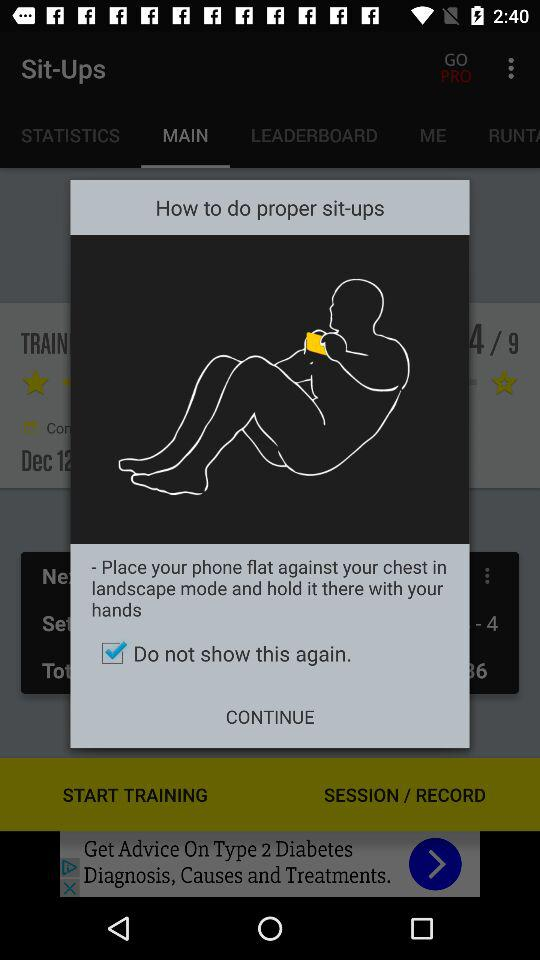How to hold the phone while doing sit-ups? While doing sit-ups, hold the phone with your hands. 